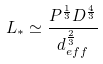Convert formula to latex. <formula><loc_0><loc_0><loc_500><loc_500>L _ { \ast } \simeq \frac { P ^ { \frac { 1 } { 3 } } D ^ { \frac { 4 } { 3 } } } { d _ { e f f } ^ { \frac { 2 } { 3 } } }</formula> 